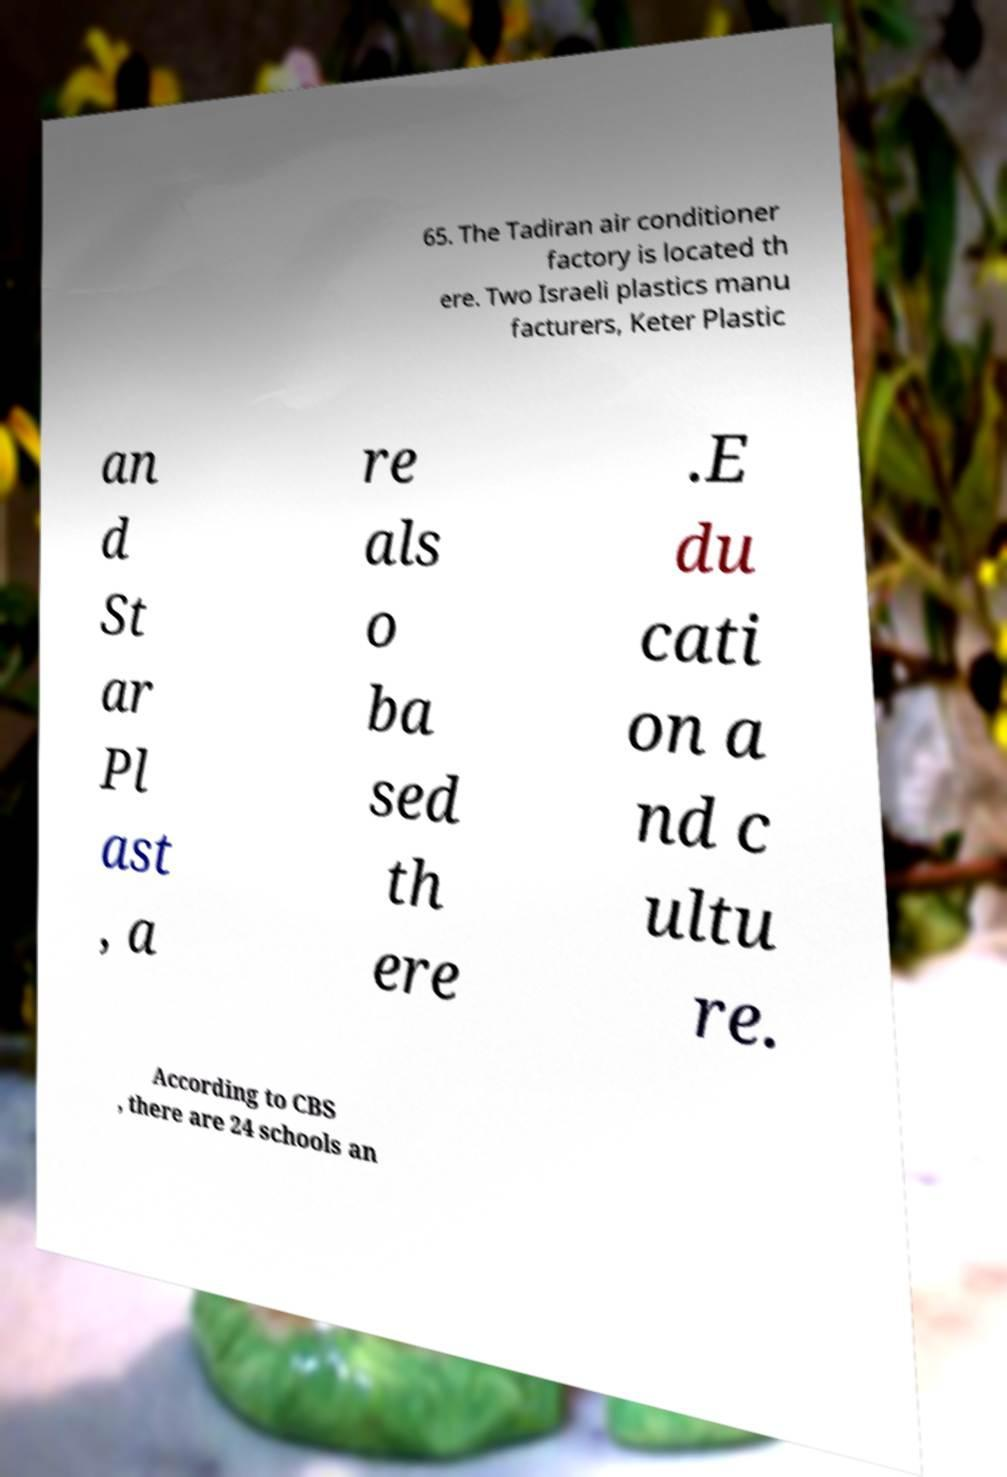What messages or text are displayed in this image? I need them in a readable, typed format. 65. The Tadiran air conditioner factory is located th ere. Two Israeli plastics manu facturers, Keter Plastic an d St ar Pl ast , a re als o ba sed th ere .E du cati on a nd c ultu re. According to CBS , there are 24 schools an 